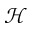Convert formula to latex. <formula><loc_0><loc_0><loc_500><loc_500>\mathcal { H }</formula> 